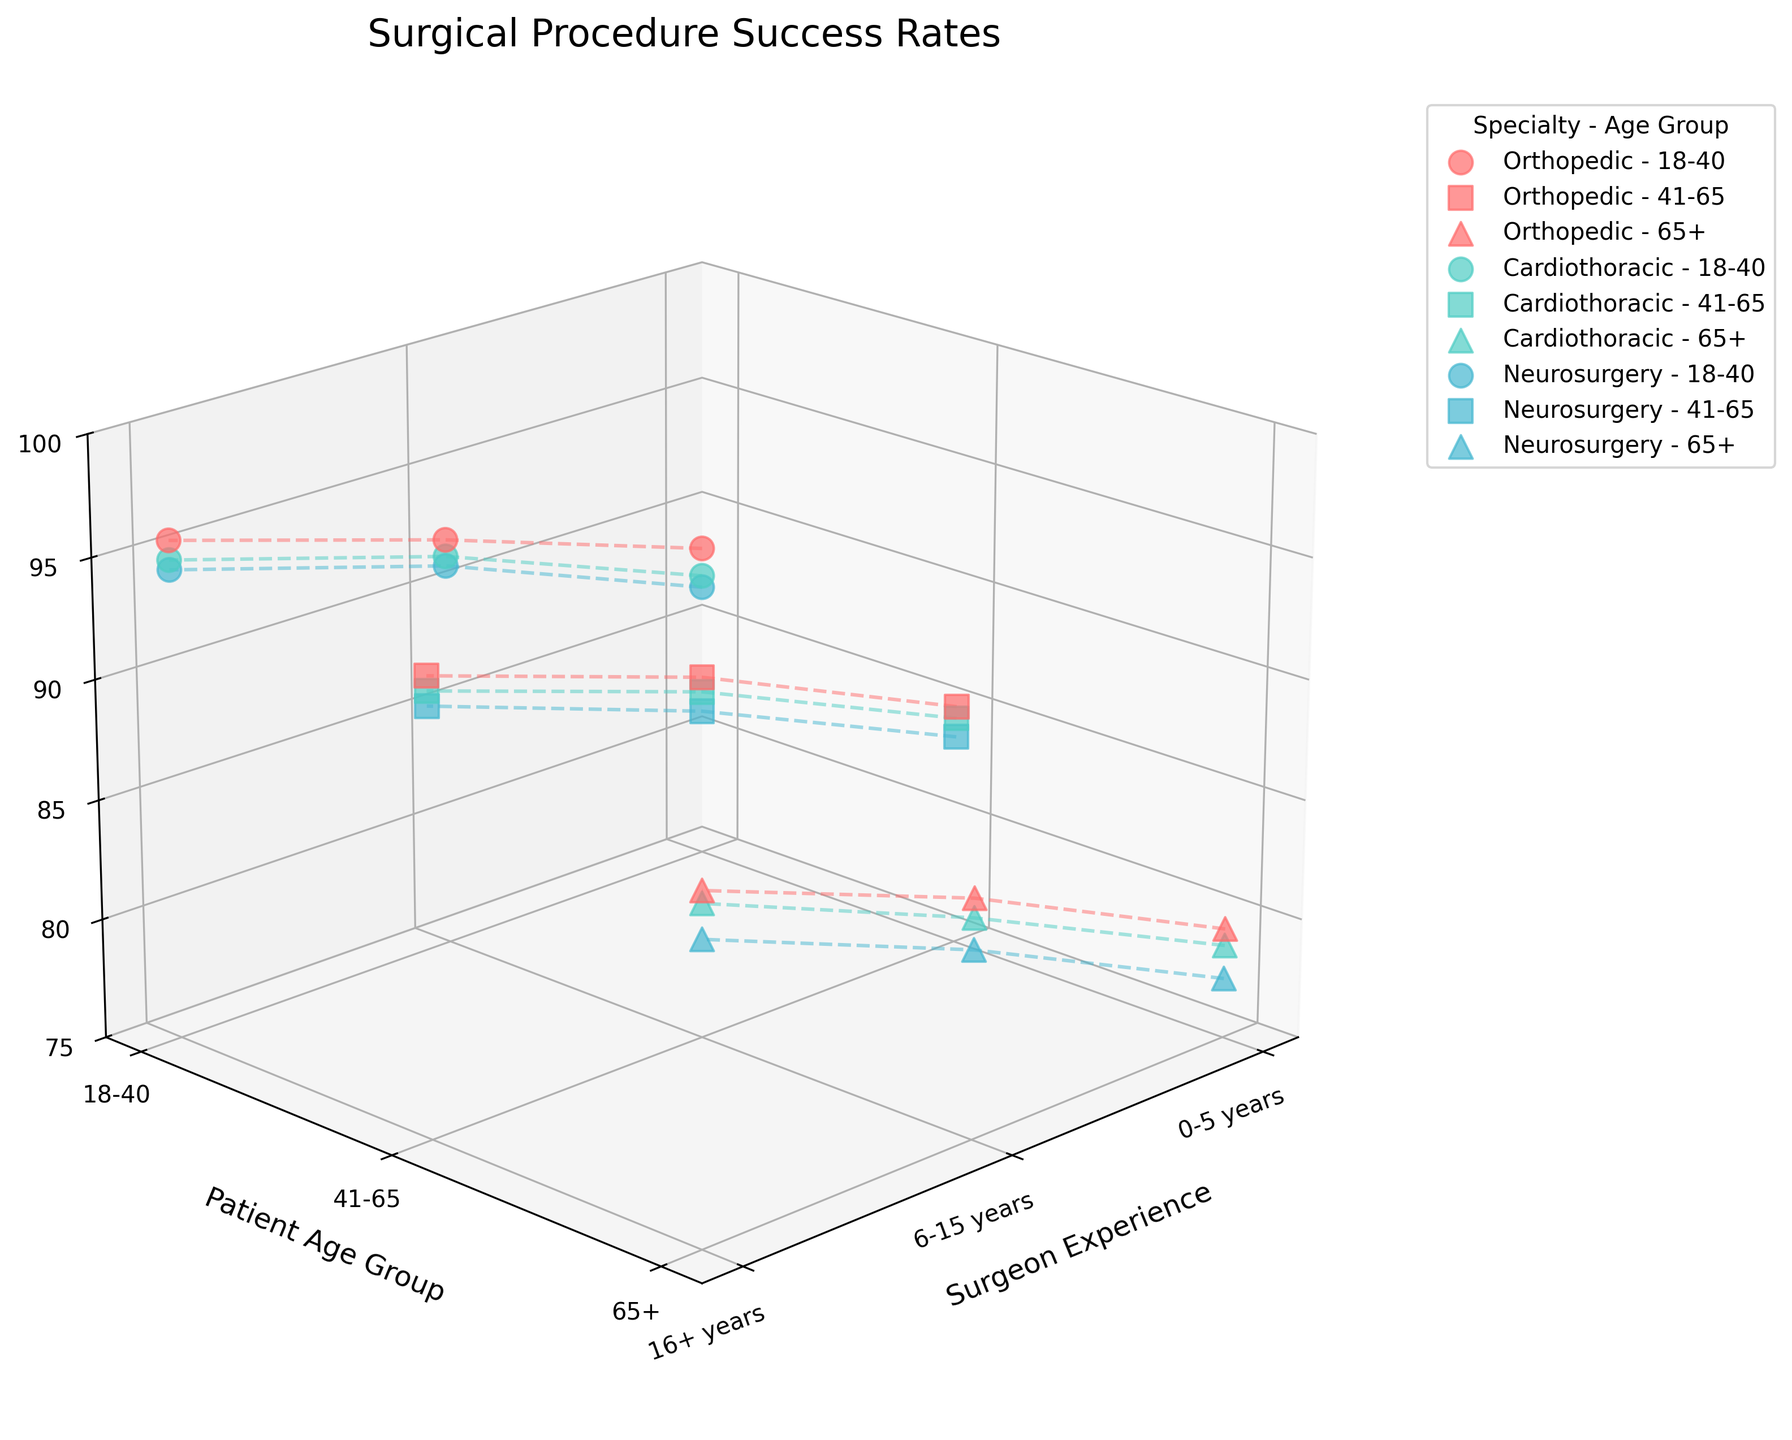What is the title of the plot? The title is displayed at the top of the plot. By reading it, we can determine what the plot represents.
Answer: Surgical Procedure Success Rates Which specialty has the highest success rate for patients aged 65+? Look at the success rates along the Z-axis for the '65+' age group and compare between specialties. The Orthopedic specialty has the highest values here.
Answer: Orthopedic How does the success rate change with increasing surgeon experience for Cardiothoracic surgeries in the 18-40 age group? Examine the trend of success rates for Cardiothoracic specialty marked with color for 18-40 age group. Observe three points from '0-5 years', '6-15 years', and '16+ years'. The rates increase with experience.
Answer: Increases What is the success rate for Neurosurgery for patients aged 41-65 with 6-15 years of experience? Find the success rate for the Neurosurgery specialty, within the 41-65 patient age group, and 6-15 years of experience.
Answer: 88.7% Among the specialties compared, which has the lowest success rate for patients aged 65+ with 0-5 years of experience? Identify the success rates for patients aged 65+ with 0-5 years of experience across the specialties. The lowest rate here is in Neurosurgery.
Answer: Neurosurgery On average, does the success rate for older age groups (65+) tend to be higher in more experienced surgeons (16+ years) across all specialties? Look at success rates for patients aged 65+ in the '16+ years' experience range across all specialties. Calculate if these rates are higher on average by comparing visually to younger experienced groups.
Answer: Yes Which age group among Cardiothoracic surgeries has the highest variability in success rates across different experience levels? Compare the range of success rates (difference between highest and lowest success rates) across the three age groups (18-40, 41-65, 65+) for Cardiothoracic specialty.
Answer: 65+ Do surgeons with 16+ years of experience always have the highest success rates across all age groups and specialties? For each specialty and age group combination, examine if the success rate for '16+ years' is the highest among the corresponding experience levels.
Answer: Yes 